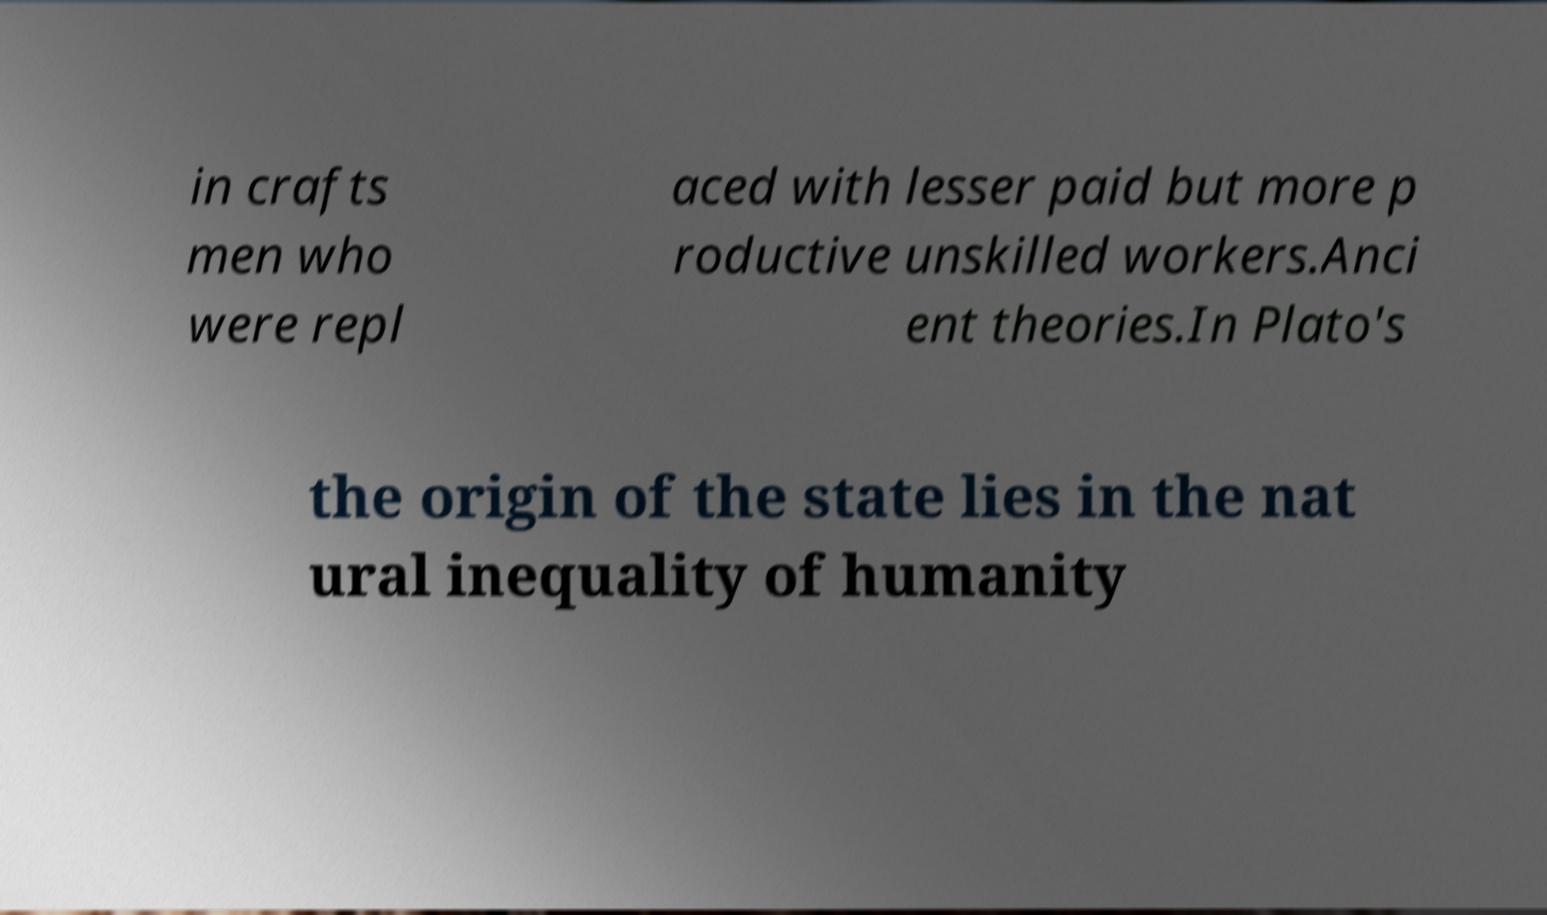Please read and relay the text visible in this image. What does it say? in crafts men who were repl aced with lesser paid but more p roductive unskilled workers.Anci ent theories.In Plato's the origin of the state lies in the nat ural inequality of humanity 